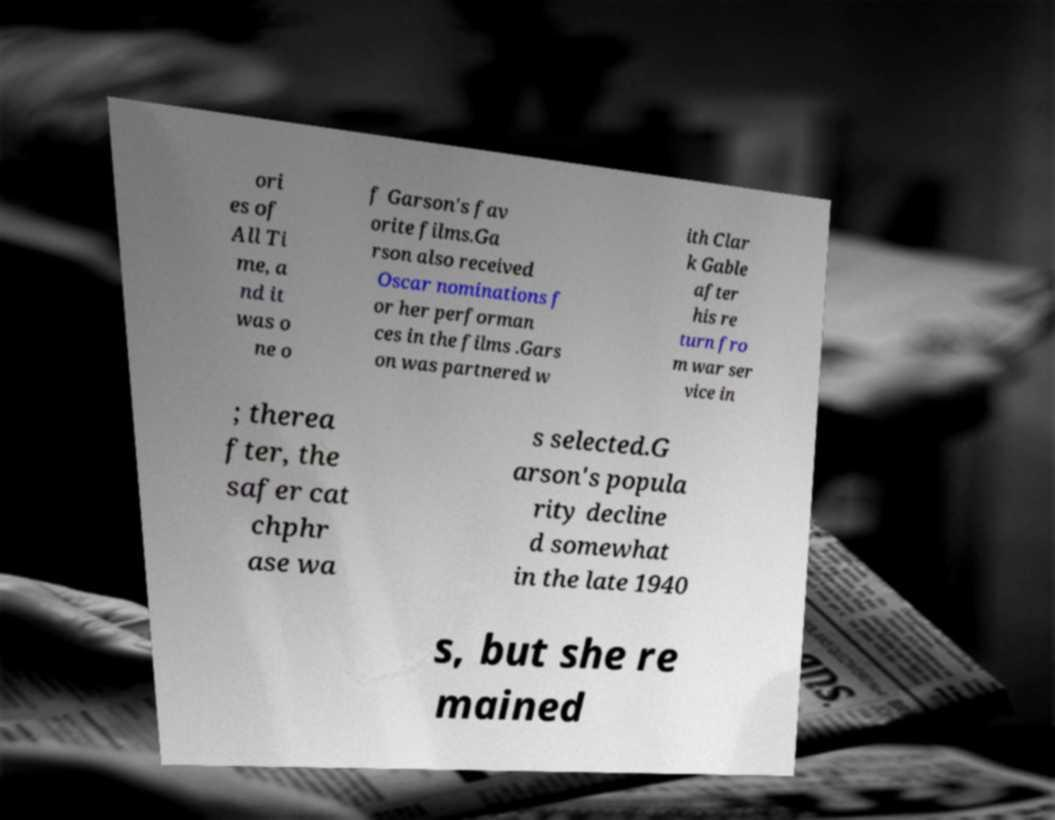Could you extract and type out the text from this image? ori es of All Ti me, a nd it was o ne o f Garson's fav orite films.Ga rson also received Oscar nominations f or her performan ces in the films .Gars on was partnered w ith Clar k Gable after his re turn fro m war ser vice in ; therea fter, the safer cat chphr ase wa s selected.G arson's popula rity decline d somewhat in the late 1940 s, but she re mained 